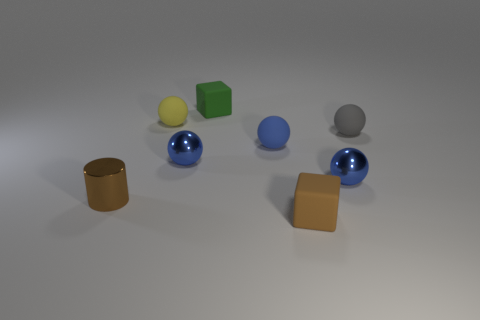Subtract all brown cylinders. How many blue spheres are left? 3 Subtract 2 balls. How many balls are left? 3 Subtract all small yellow spheres. How many spheres are left? 4 Subtract all gray balls. How many balls are left? 4 Subtract all red balls. Subtract all brown cylinders. How many balls are left? 5 Add 2 big brown shiny cubes. How many objects exist? 10 Subtract all cylinders. How many objects are left? 7 Add 3 tiny cylinders. How many tiny cylinders exist? 4 Subtract 0 red balls. How many objects are left? 8 Subtract all green things. Subtract all shiny balls. How many objects are left? 5 